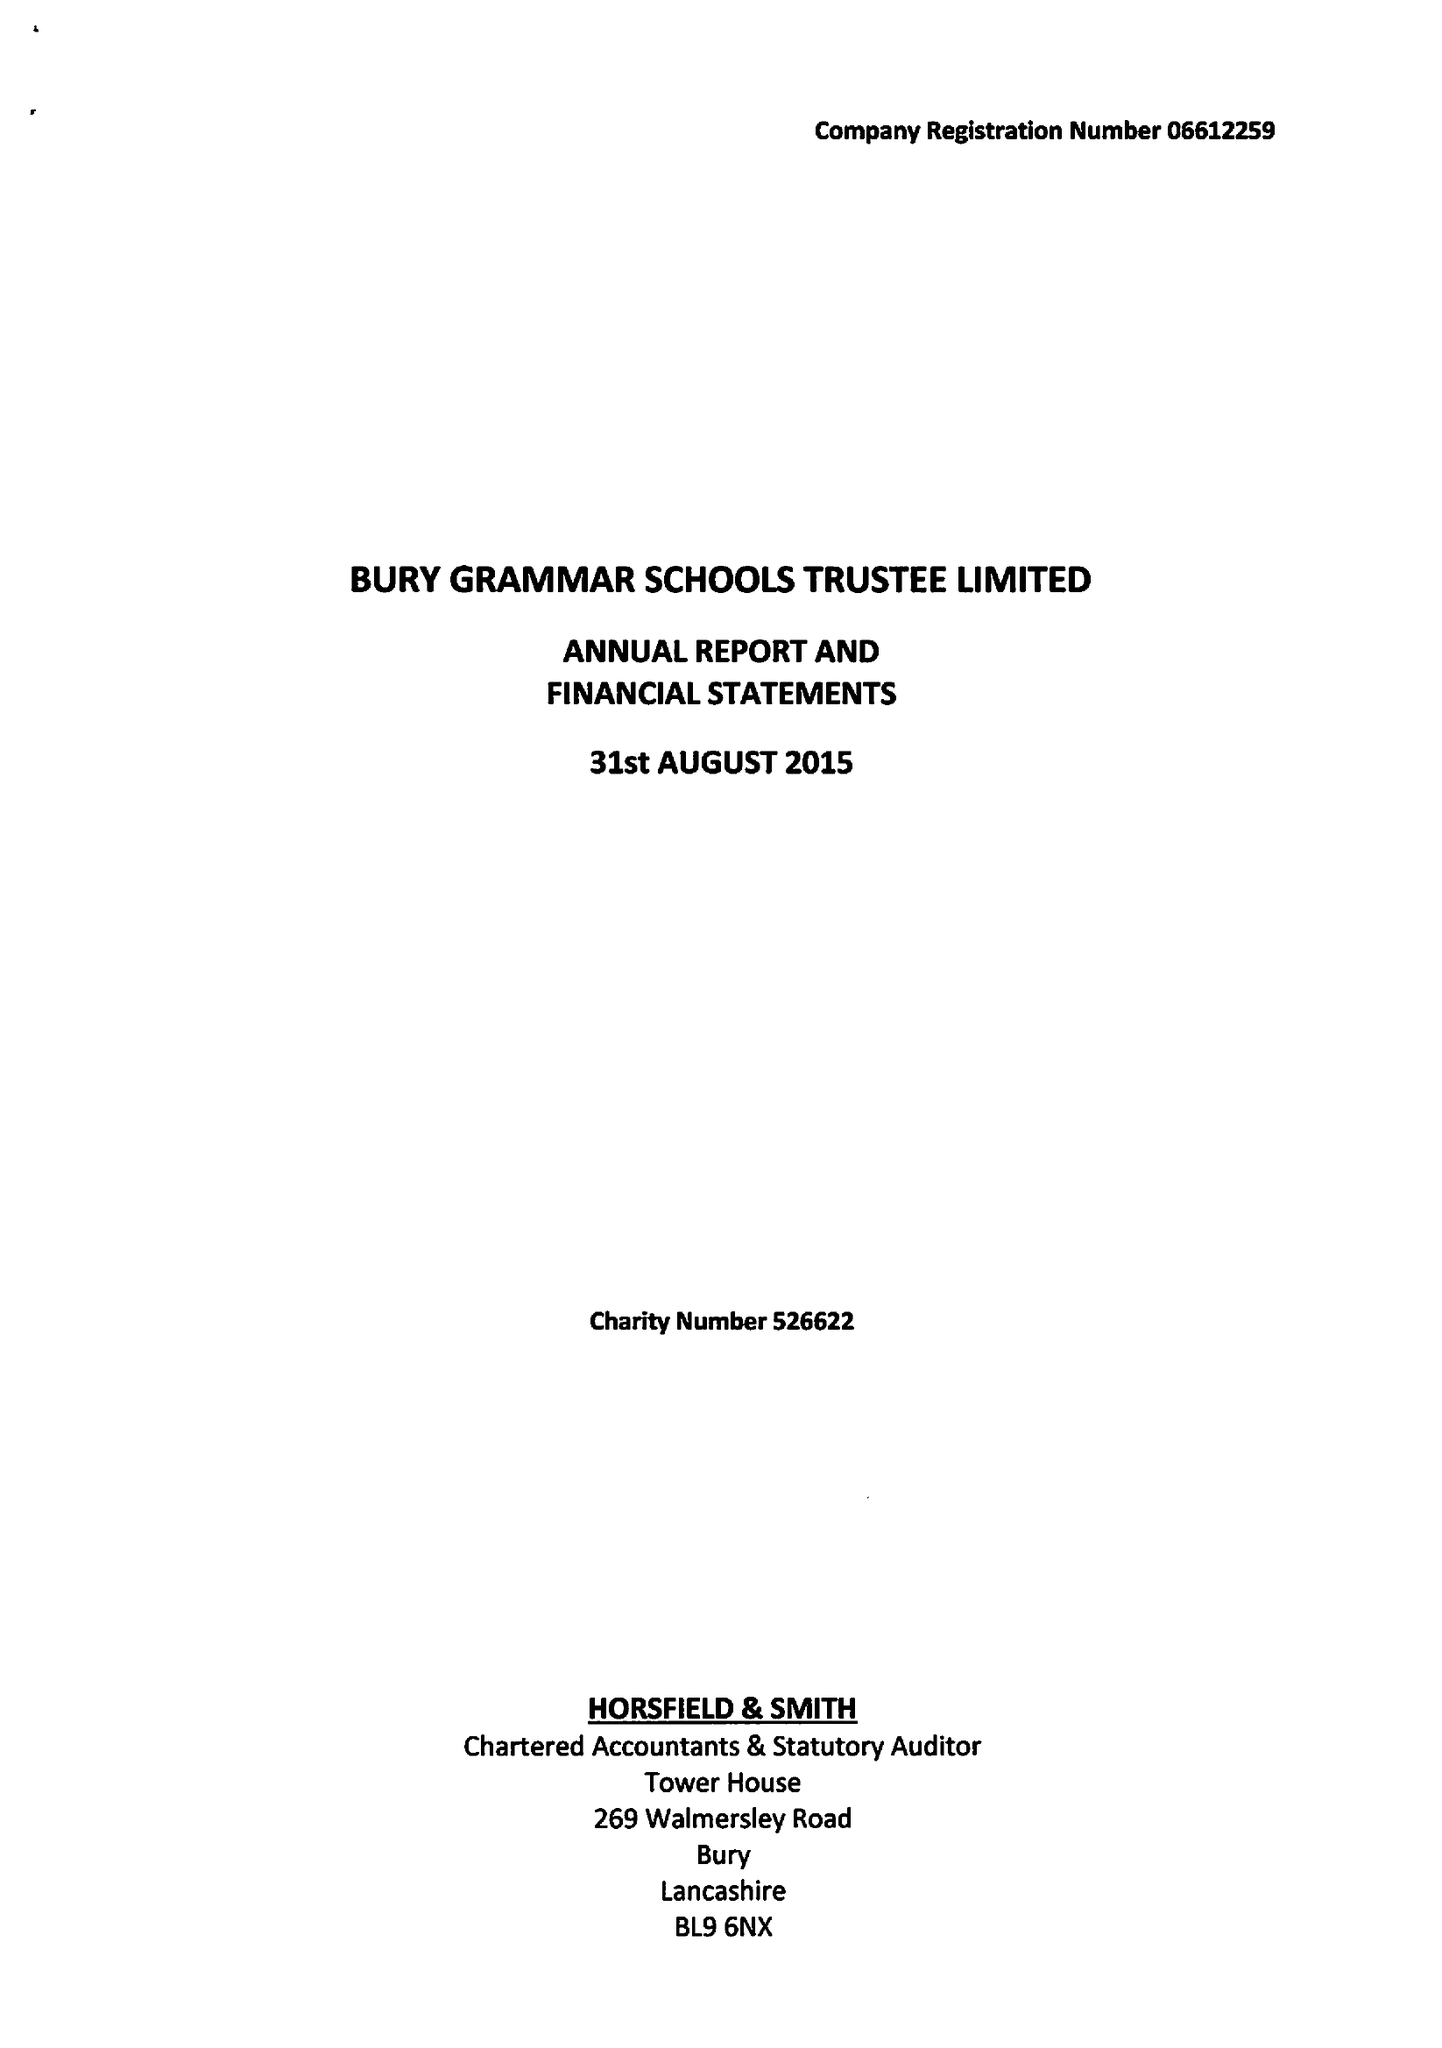What is the value for the charity_name?
Answer the question using a single word or phrase. Bury Grammar Schools Trustee Ltd. 